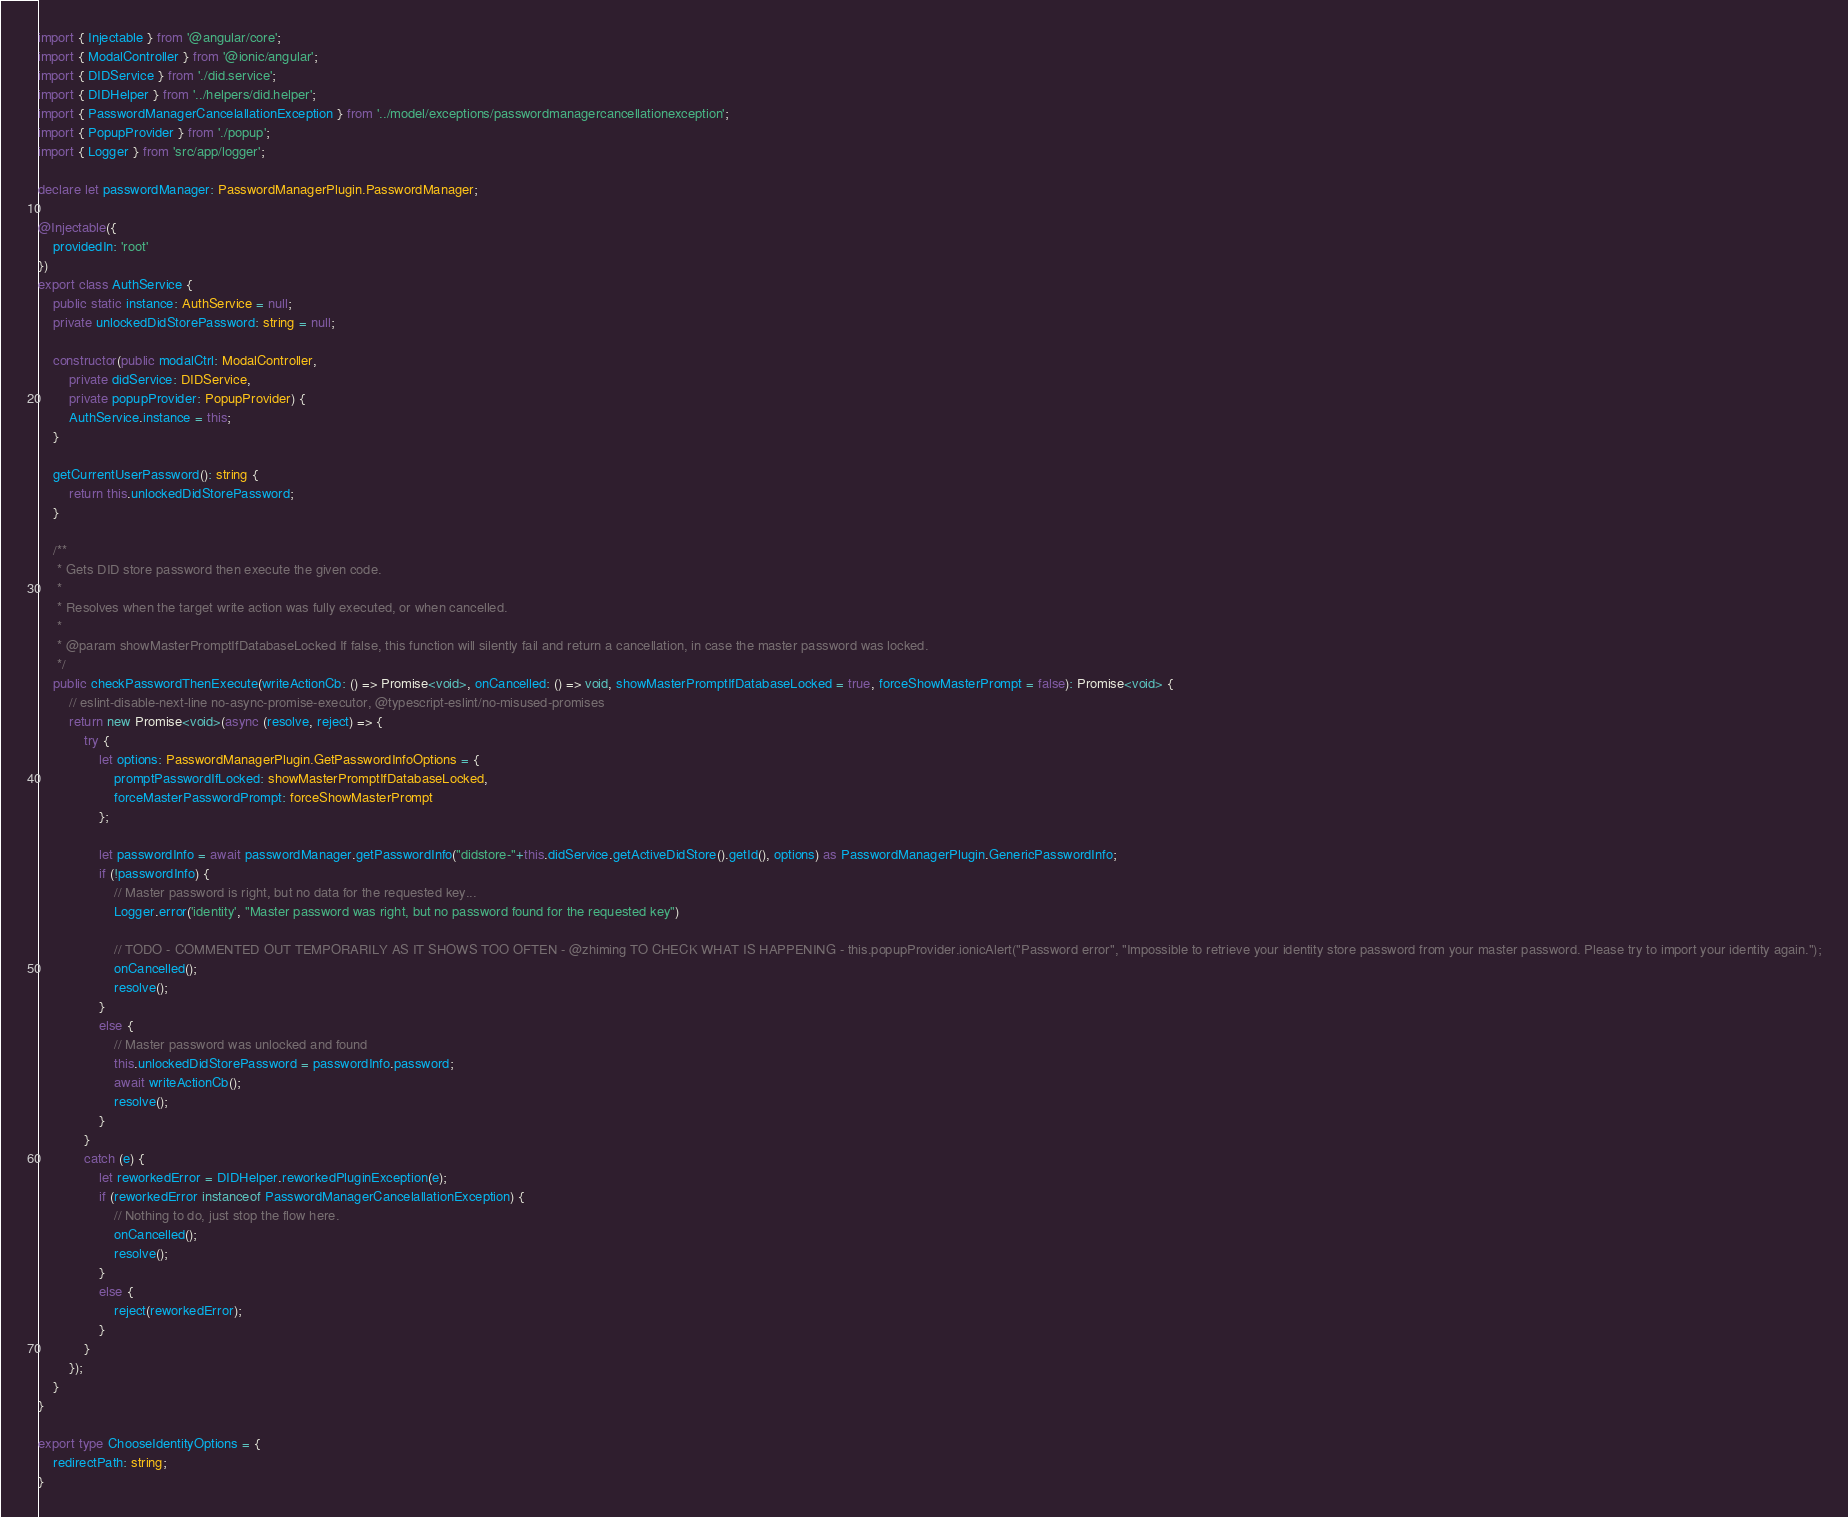<code> <loc_0><loc_0><loc_500><loc_500><_TypeScript_>import { Injectable } from '@angular/core';
import { ModalController } from '@ionic/angular';
import { DIDService } from './did.service';
import { DIDHelper } from '../helpers/did.helper';
import { PasswordManagerCancelallationException } from '../model/exceptions/passwordmanagercancellationexception';
import { PopupProvider } from './popup';
import { Logger } from 'src/app/logger';

declare let passwordManager: PasswordManagerPlugin.PasswordManager;

@Injectable({
    providedIn: 'root'
})
export class AuthService {
    public static instance: AuthService = null;
    private unlockedDidStorePassword: string = null;

    constructor(public modalCtrl: ModalController,
        private didService: DIDService,
        private popupProvider: PopupProvider) {
        AuthService.instance = this;
    }

    getCurrentUserPassword(): string {
        return this.unlockedDidStorePassword;
    }

    /**
     * Gets DID store password then execute the given code.
     * 
     * Resolves when the target write action was fully executed, or when cancelled.
     *
     * @param showMasterPromptIfDatabaseLocked If false, this function will silently fail and return a cancellation, in case the master password was locked.
     */
    public checkPasswordThenExecute(writeActionCb: () => Promise<void>, onCancelled: () => void, showMasterPromptIfDatabaseLocked = true, forceShowMasterPrompt = false): Promise<void> {
        // eslint-disable-next-line no-async-promise-executor, @typescript-eslint/no-misused-promises
        return new Promise<void>(async (resolve, reject) => {
            try {
                let options: PasswordManagerPlugin.GetPasswordInfoOptions = {
                    promptPasswordIfLocked: showMasterPromptIfDatabaseLocked,
                    forceMasterPasswordPrompt: forceShowMasterPrompt
                };

                let passwordInfo = await passwordManager.getPasswordInfo("didstore-"+this.didService.getActiveDidStore().getId(), options) as PasswordManagerPlugin.GenericPasswordInfo;
                if (!passwordInfo) {
                    // Master password is right, but no data for the requested key...
                    Logger.error('identity', "Master password was right, but no password found for the requested key")

                    // TODO - COMMENTED OUT TEMPORARILY AS IT SHOWS TOO OFTEN - @zhiming TO CHECK WHAT IS HAPPENING - this.popupProvider.ionicAlert("Password error", "Impossible to retrieve your identity store password from your master password. Please try to import your identity again.");
                    onCancelled();
                    resolve();
                }
                else {
                    // Master password was unlocked and found
                    this.unlockedDidStorePassword = passwordInfo.password;
                    await writeActionCb();
                    resolve();
                }
            }
            catch (e) {
                let reworkedError = DIDHelper.reworkedPluginException(e);
                if (reworkedError instanceof PasswordManagerCancelallationException) {
                    // Nothing to do, just stop the flow here.
                    onCancelled();
                    resolve();
                }
                else {
                    reject(reworkedError);
                }
            }
        });
    }
}

export type ChooseIdentityOptions = {
    redirectPath: string;
}
</code> 